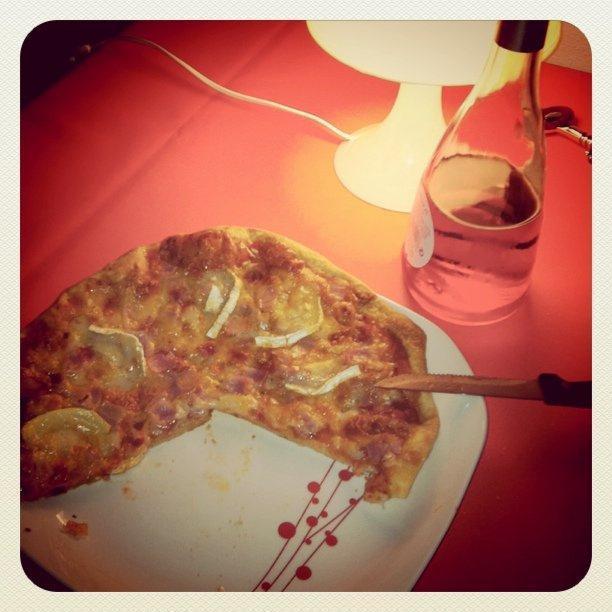How many toys are in the dog bed?
Give a very brief answer. 0. 